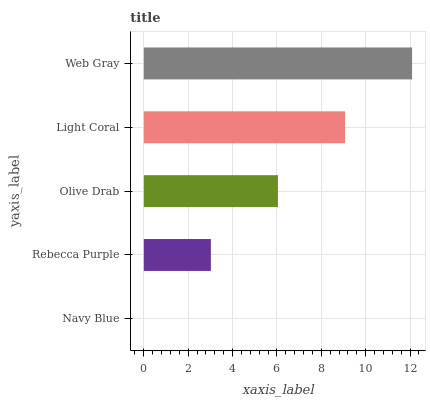Is Navy Blue the minimum?
Answer yes or no. Yes. Is Web Gray the maximum?
Answer yes or no. Yes. Is Rebecca Purple the minimum?
Answer yes or no. No. Is Rebecca Purple the maximum?
Answer yes or no. No. Is Rebecca Purple greater than Navy Blue?
Answer yes or no. Yes. Is Navy Blue less than Rebecca Purple?
Answer yes or no. Yes. Is Navy Blue greater than Rebecca Purple?
Answer yes or no. No. Is Rebecca Purple less than Navy Blue?
Answer yes or no. No. Is Olive Drab the high median?
Answer yes or no. Yes. Is Olive Drab the low median?
Answer yes or no. Yes. Is Navy Blue the high median?
Answer yes or no. No. Is Rebecca Purple the low median?
Answer yes or no. No. 